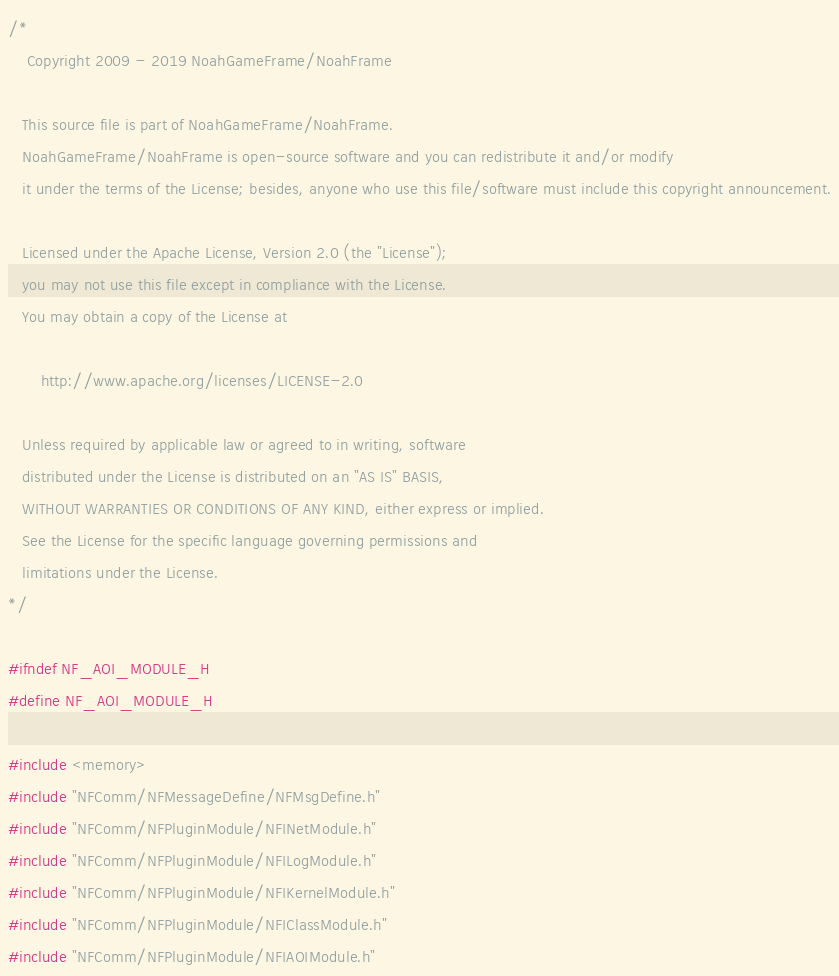<code> <loc_0><loc_0><loc_500><loc_500><_C_>/*
    Copyright 2009 - 2019 NoahGameFrame/NoahFrame
    
   This source file is part of NoahGameFrame/NoahFrame.
   NoahGameFrame/NoahFrame is open-source software and you can redistribute it and/or modify
   it under the terms of the License; besides, anyone who use this file/software must include this copyright announcement.

   Licensed under the Apache License, Version 2.0 (the "License");
   you may not use this file except in compliance with the License.
   You may obtain a copy of the License at

       http://www.apache.org/licenses/LICENSE-2.0

   Unless required by applicable law or agreed to in writing, software
   distributed under the License is distributed on an "AS IS" BASIS,
   WITHOUT WARRANTIES OR CONDITIONS OF ANY KIND, either express or implied.
   See the License for the specific language governing permissions and
   limitations under the License.
*/

#ifndef NF_AOI_MODULE_H
#define NF_AOI_MODULE_H

#include <memory>
#include "NFComm/NFMessageDefine/NFMsgDefine.h"
#include "NFComm/NFPluginModule/NFINetModule.h"
#include "NFComm/NFPluginModule/NFILogModule.h"
#include "NFComm/NFPluginModule/NFIKernelModule.h"
#include "NFComm/NFPluginModule/NFIClassModule.h"
#include "NFComm/NFPluginModule/NFIAOIModule.h"</code> 